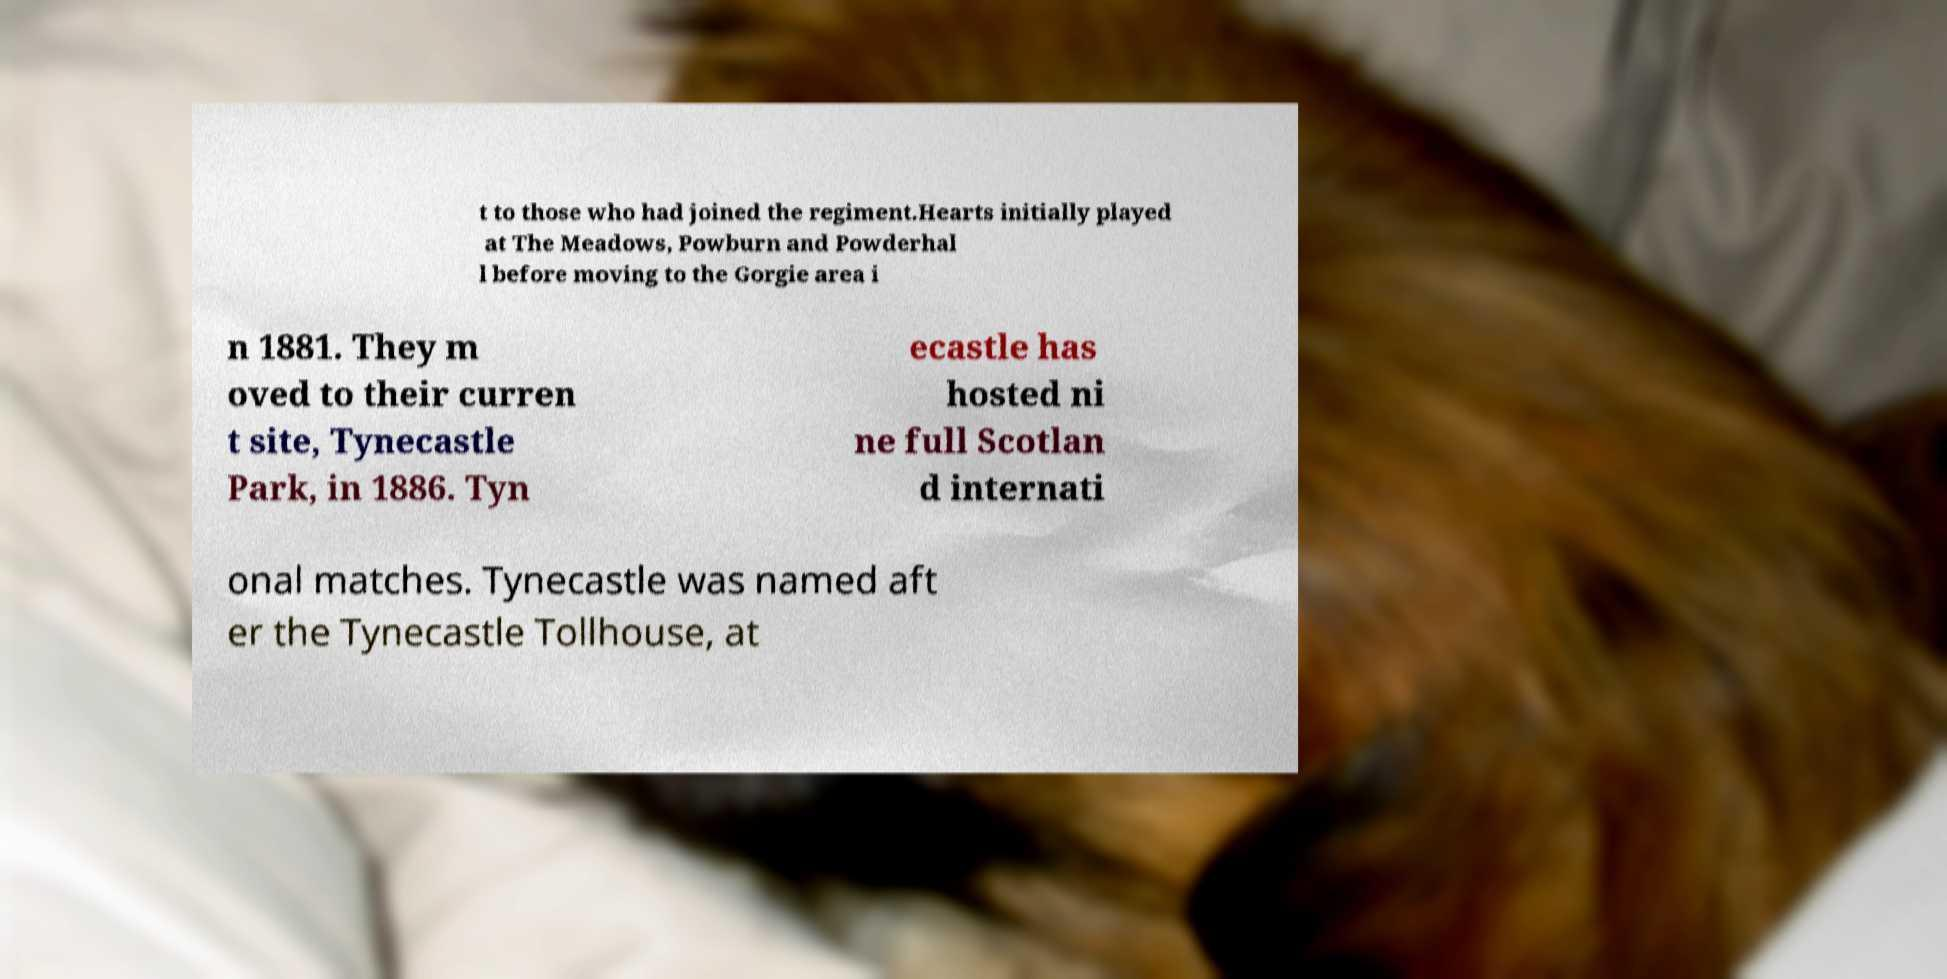For documentation purposes, I need the text within this image transcribed. Could you provide that? t to those who had joined the regiment.Hearts initially played at The Meadows, Powburn and Powderhal l before moving to the Gorgie area i n 1881. They m oved to their curren t site, Tynecastle Park, in 1886. Tyn ecastle has hosted ni ne full Scotlan d internati onal matches. Tynecastle was named aft er the Tynecastle Tollhouse, at 